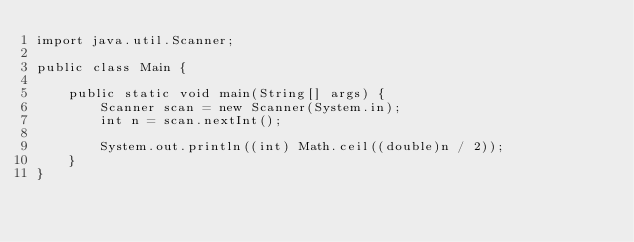<code> <loc_0><loc_0><loc_500><loc_500><_Java_>import java.util.Scanner;

public class Main {

    public static void main(String[] args) {
        Scanner scan = new Scanner(System.in);
        int n = scan.nextInt();

        System.out.println((int) Math.ceil((double)n / 2));
    }
}
</code> 